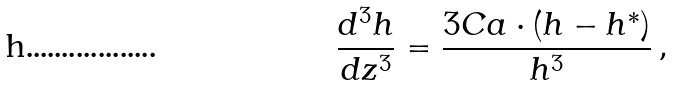Convert formula to latex. <formula><loc_0><loc_0><loc_500><loc_500>\frac { d ^ { 3 } h } { d z ^ { 3 } } = \frac { 3 C a \cdot ( h - h ^ { * } ) } { h ^ { 3 } } \, ,</formula> 